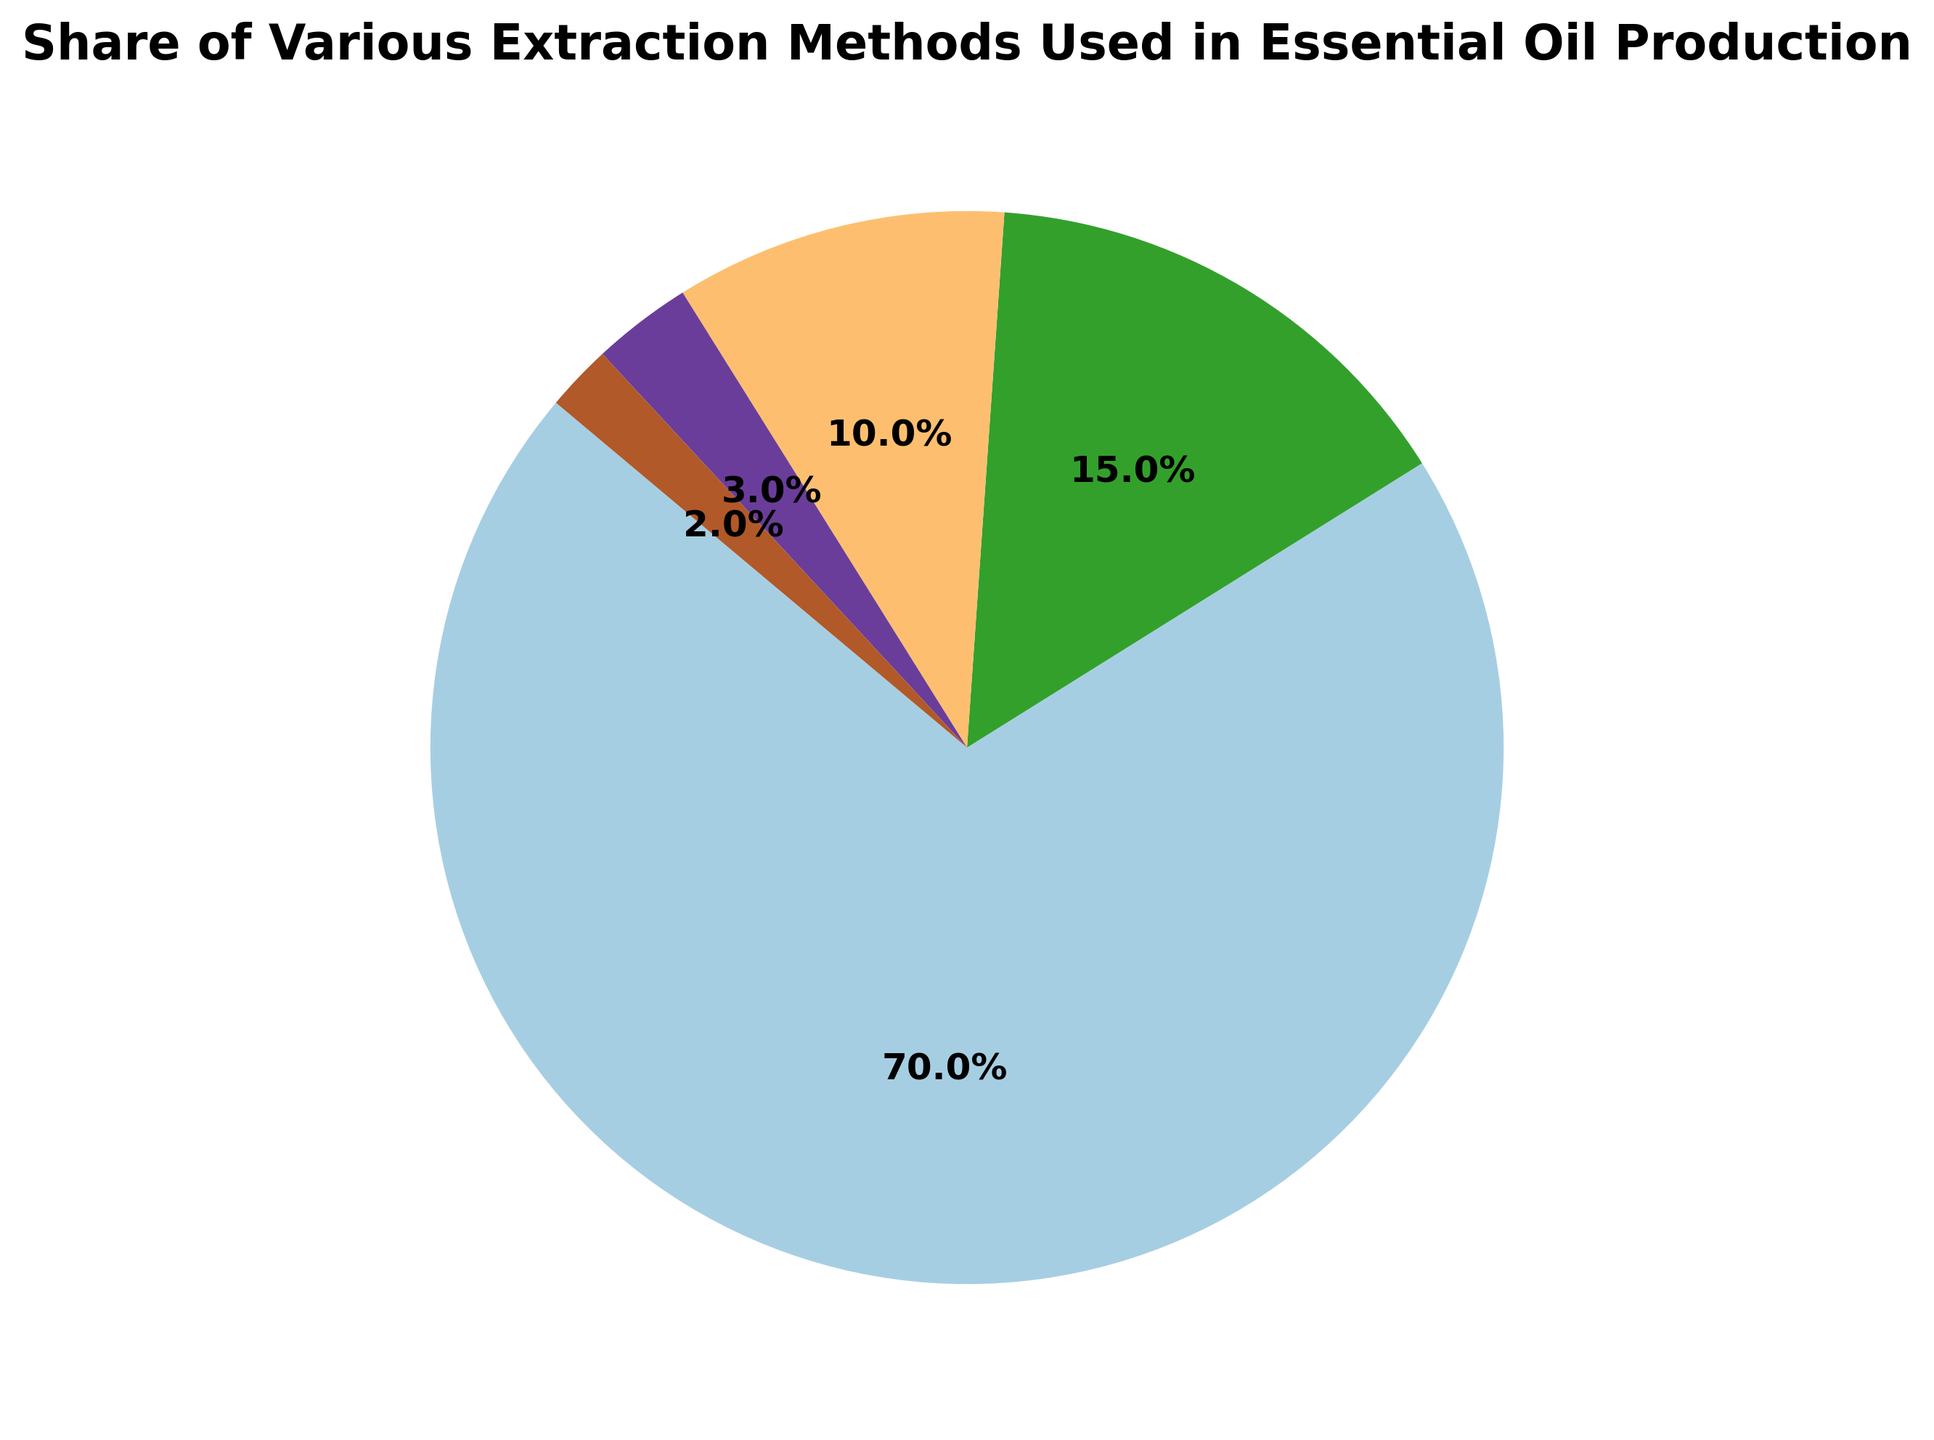what percentage of the total share do Cold Pressing and Solvent Extraction methods account for together? To determine the combined share of Cold Pressing and Solvent Extraction methods, locate their percentages in the pie chart: Cold Pressing is 15%, and Solvent Extraction is 10%. Add these two percentages together: 15% + 10% = 25%.
Answer: 25% Which extraction method accounts for the smallest share of essential oil production? Identify the method with the smallest percentage on the pie chart. Hydrodistillation has the smallest share at 2%.
Answer: Hydrodistillation By how much is the share of Steam Distillation greater than the share of CO2 Extraction? Find the percentages for Steam Distillation and CO2 Extraction methods: Steam Distillation is 70% and CO2 Extraction is 3%. Subtract the percentage of CO2 Extraction from Steam Distillation: 70% - 3% = 67%.
Answer: 67% Which methods have a combined share of 5%? Look for methods whose shares add up to 5%. The two smallest shares are 3% (CO2 Extraction) and 2% (Hydrodistillation). Adding these together: 3% + 2% = 5%.
Answer: CO2 Extraction and Hydrodistillation How many methods account for less than 20% of the total share each? Identify the methods with shares less than 20% by inspecting the pie chart. These are Cold Pressing (15%), Solvent Extraction (10%), CO2 Extraction (3%), and Hydrodistillation (2%). There are four methods in this category.
Answer: 4 What is the average share percentage of all the extraction methods displayed in the chart? To find the average share, add the percentages of all methods and divide by the number of methods. The shares are: 70, 15, 10, 3, and 2. Sum them: 70 + 15 + 10 + 3 + 2 = 100. Divide by the number of methods (5): 100 / 5 = 20%.
Answer: 20% What proportion of the total share is represented by non-distillation methods? Identify the shares of non-distillation methods: Cold Pressing (15%), Solvent Extraction (10%), and CO2 Extraction (3%). Add these percentages: 15% + 10% + 3% = 28%.
Answer: 28% Which extraction method is second in terms of share, and what is its percentage? Identify the method with the second-largest share. Cold Pressing has the second-largest share at 15%.
Answer: Cold Pressing, 15% What is the difference between the shares of Solvent Extraction and Cold Pressing methods? Find the percentages for Solvent Extraction (10%) and Cold Pressing (15%). Subtract the percentage of Solvent Extraction from Cold Pressing: 15% - 10% = 5%.
Answer: 5% 